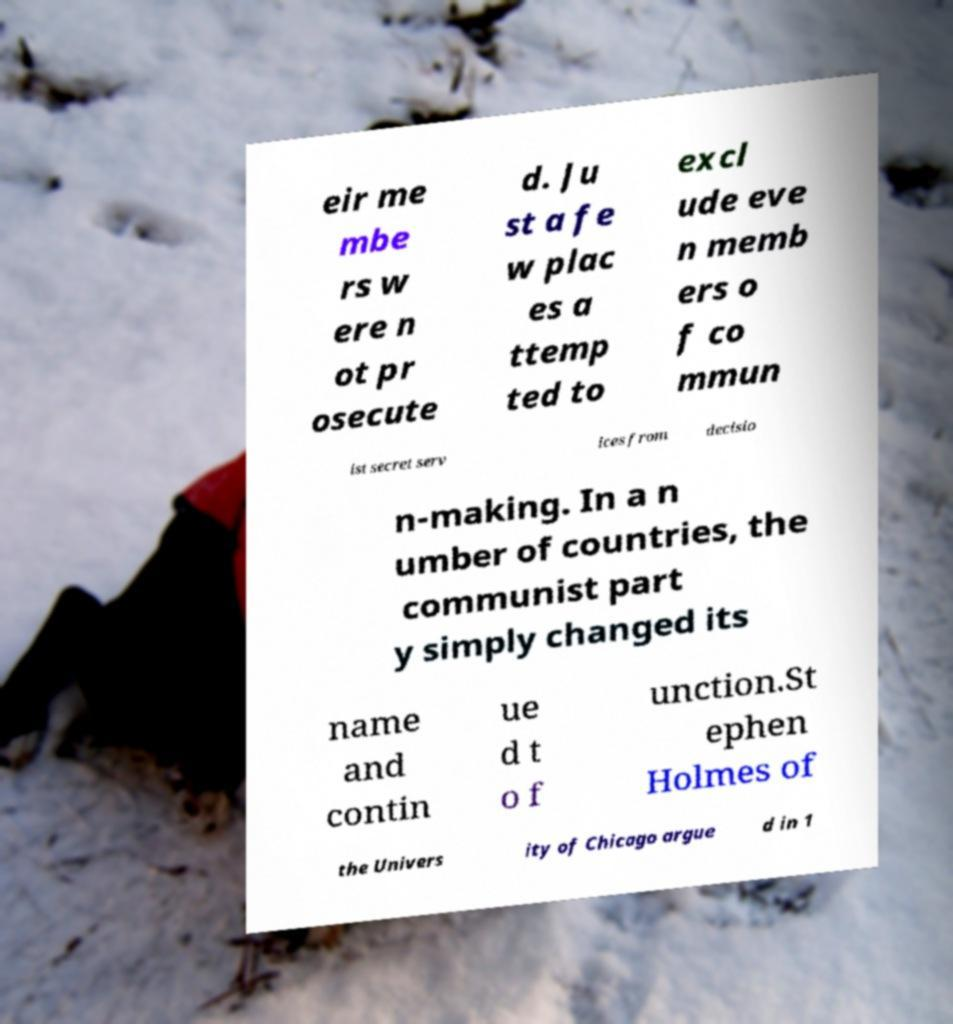Can you accurately transcribe the text from the provided image for me? eir me mbe rs w ere n ot pr osecute d. Ju st a fe w plac es a ttemp ted to excl ude eve n memb ers o f co mmun ist secret serv ices from decisio n-making. In a n umber of countries, the communist part y simply changed its name and contin ue d t o f unction.St ephen Holmes of the Univers ity of Chicago argue d in 1 